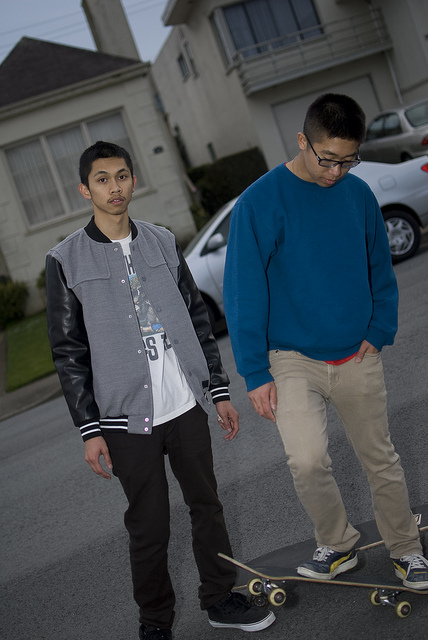How many cars are there? In the background, there appears to be just one car parked on the side of the street behind the two individuals. 